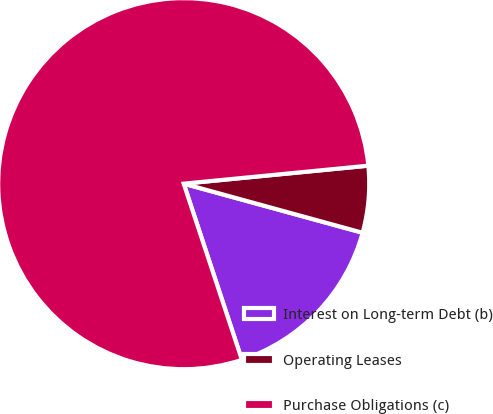Convert chart to OTSL. <chart><loc_0><loc_0><loc_500><loc_500><pie_chart><fcel>Interest on Long-term Debt (b)<fcel>Operating Leases<fcel>Purchase Obligations (c)<nl><fcel>15.66%<fcel>5.81%<fcel>78.53%<nl></chart> 